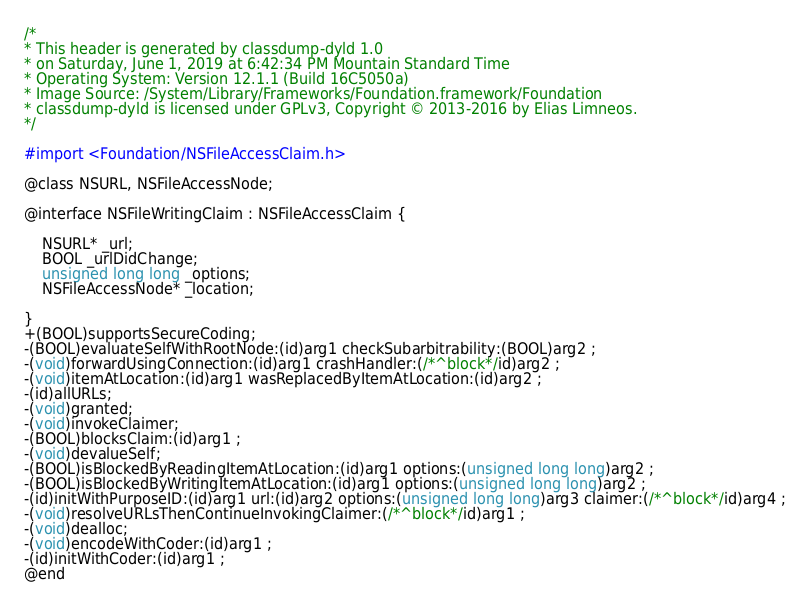Convert code to text. <code><loc_0><loc_0><loc_500><loc_500><_C_>/*
* This header is generated by classdump-dyld 1.0
* on Saturday, June 1, 2019 at 6:42:34 PM Mountain Standard Time
* Operating System: Version 12.1.1 (Build 16C5050a)
* Image Source: /System/Library/Frameworks/Foundation.framework/Foundation
* classdump-dyld is licensed under GPLv3, Copyright © 2013-2016 by Elias Limneos.
*/

#import <Foundation/NSFileAccessClaim.h>

@class NSURL, NSFileAccessNode;

@interface NSFileWritingClaim : NSFileAccessClaim {

	NSURL* _url;
	BOOL _urlDidChange;
	unsigned long long _options;
	NSFileAccessNode* _location;

}
+(BOOL)supportsSecureCoding;
-(BOOL)evaluateSelfWithRootNode:(id)arg1 checkSubarbitrability:(BOOL)arg2 ;
-(void)forwardUsingConnection:(id)arg1 crashHandler:(/*^block*/id)arg2 ;
-(void)itemAtLocation:(id)arg1 wasReplacedByItemAtLocation:(id)arg2 ;
-(id)allURLs;
-(void)granted;
-(void)invokeClaimer;
-(BOOL)blocksClaim:(id)arg1 ;
-(void)devalueSelf;
-(BOOL)isBlockedByReadingItemAtLocation:(id)arg1 options:(unsigned long long)arg2 ;
-(BOOL)isBlockedByWritingItemAtLocation:(id)arg1 options:(unsigned long long)arg2 ;
-(id)initWithPurposeID:(id)arg1 url:(id)arg2 options:(unsigned long long)arg3 claimer:(/*^block*/id)arg4 ;
-(void)resolveURLsThenContinueInvokingClaimer:(/*^block*/id)arg1 ;
-(void)dealloc;
-(void)encodeWithCoder:(id)arg1 ;
-(id)initWithCoder:(id)arg1 ;
@end

</code> 